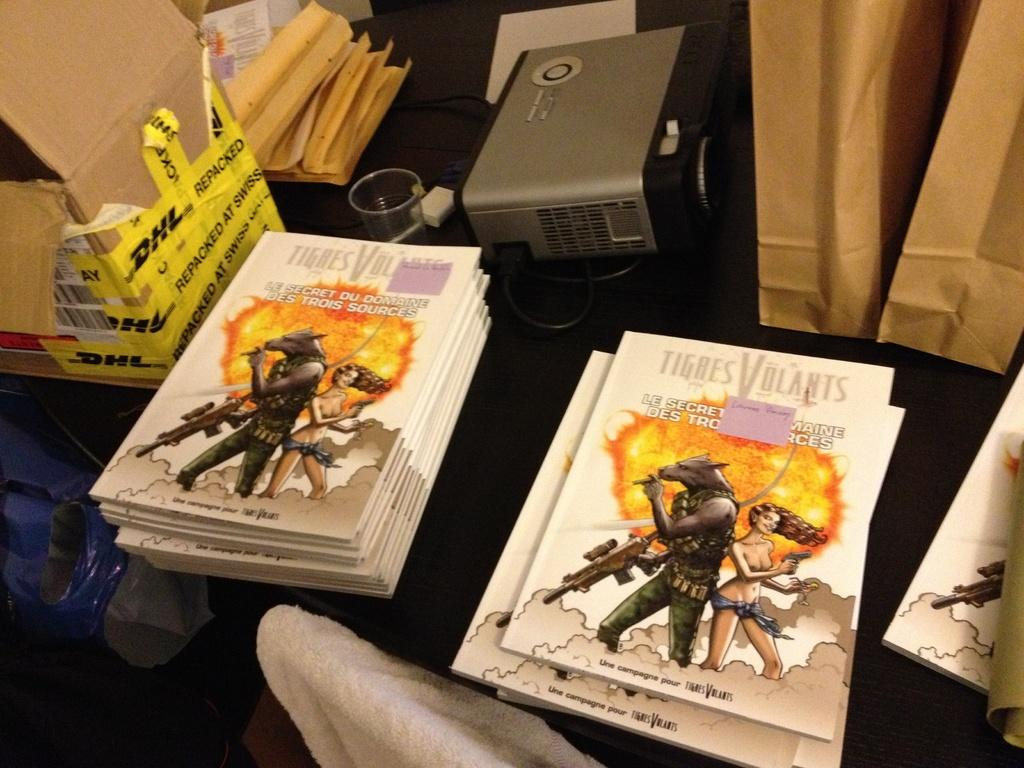<image>
Describe the image concisely. Tigres Volants features a wolf and a beautiful girl on the cover. 